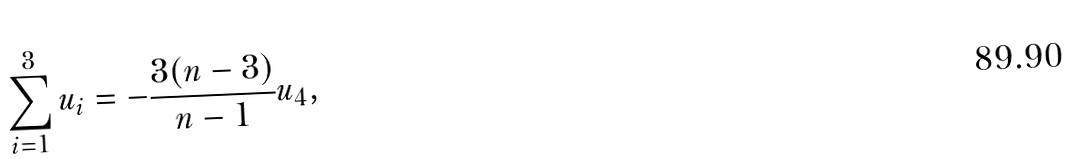<formula> <loc_0><loc_0><loc_500><loc_500>\sum _ { i = 1 } ^ { 3 } u _ { i } = - \frac { 3 ( n - 3 ) } { n - 1 } u _ { 4 } ,</formula> 